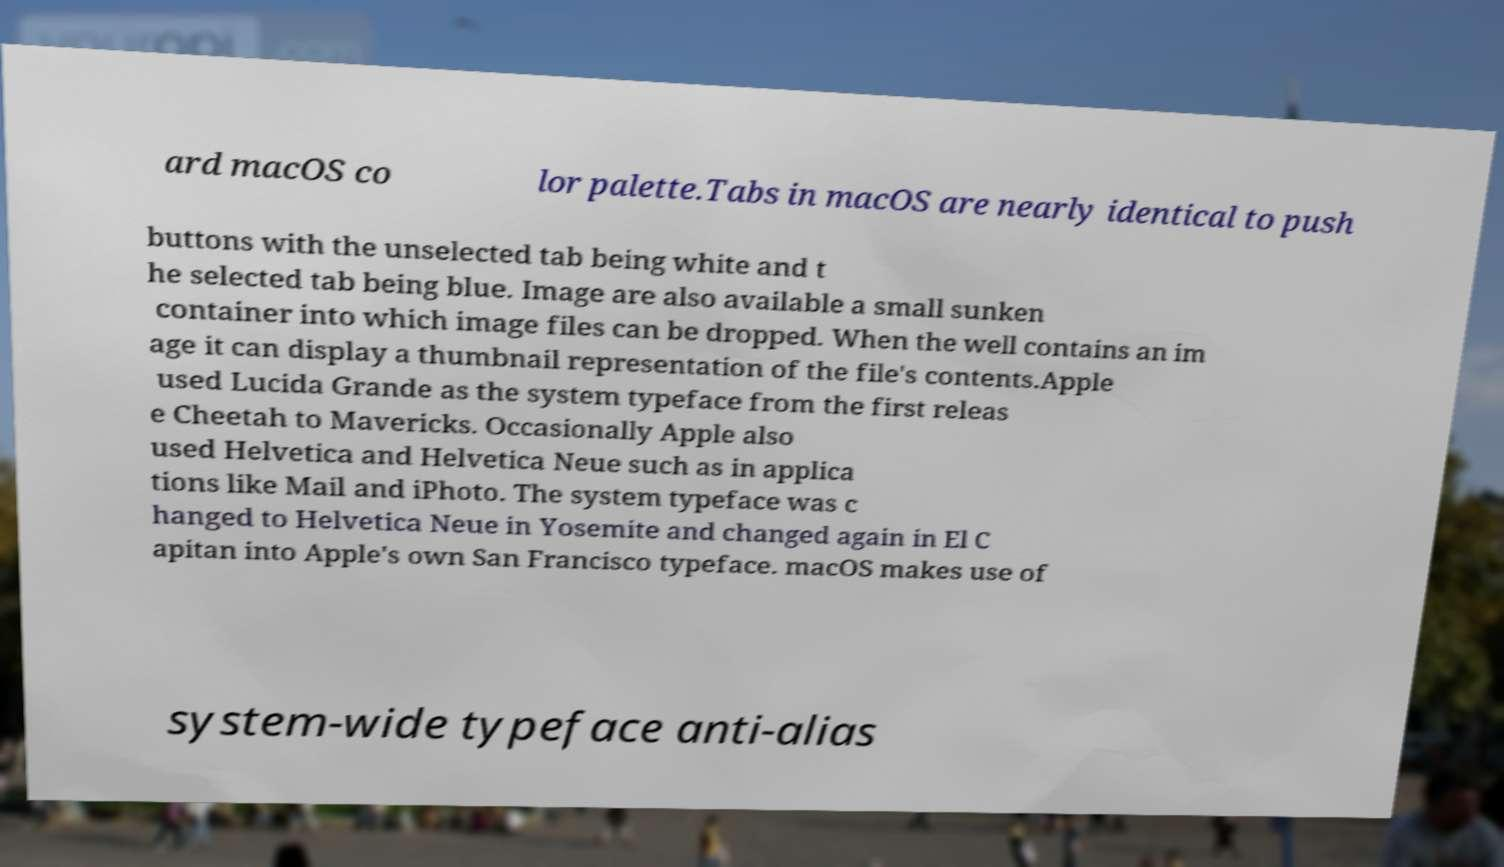What messages or text are displayed in this image? I need them in a readable, typed format. ard macOS co lor palette.Tabs in macOS are nearly identical to push buttons with the unselected tab being white and t he selected tab being blue. Image are also available a small sunken container into which image files can be dropped. When the well contains an im age it can display a thumbnail representation of the file's contents.Apple used Lucida Grande as the system typeface from the first releas e Cheetah to Mavericks. Occasionally Apple also used Helvetica and Helvetica Neue such as in applica tions like Mail and iPhoto. The system typeface was c hanged to Helvetica Neue in Yosemite and changed again in El C apitan into Apple's own San Francisco typeface. macOS makes use of system-wide typeface anti-alias 